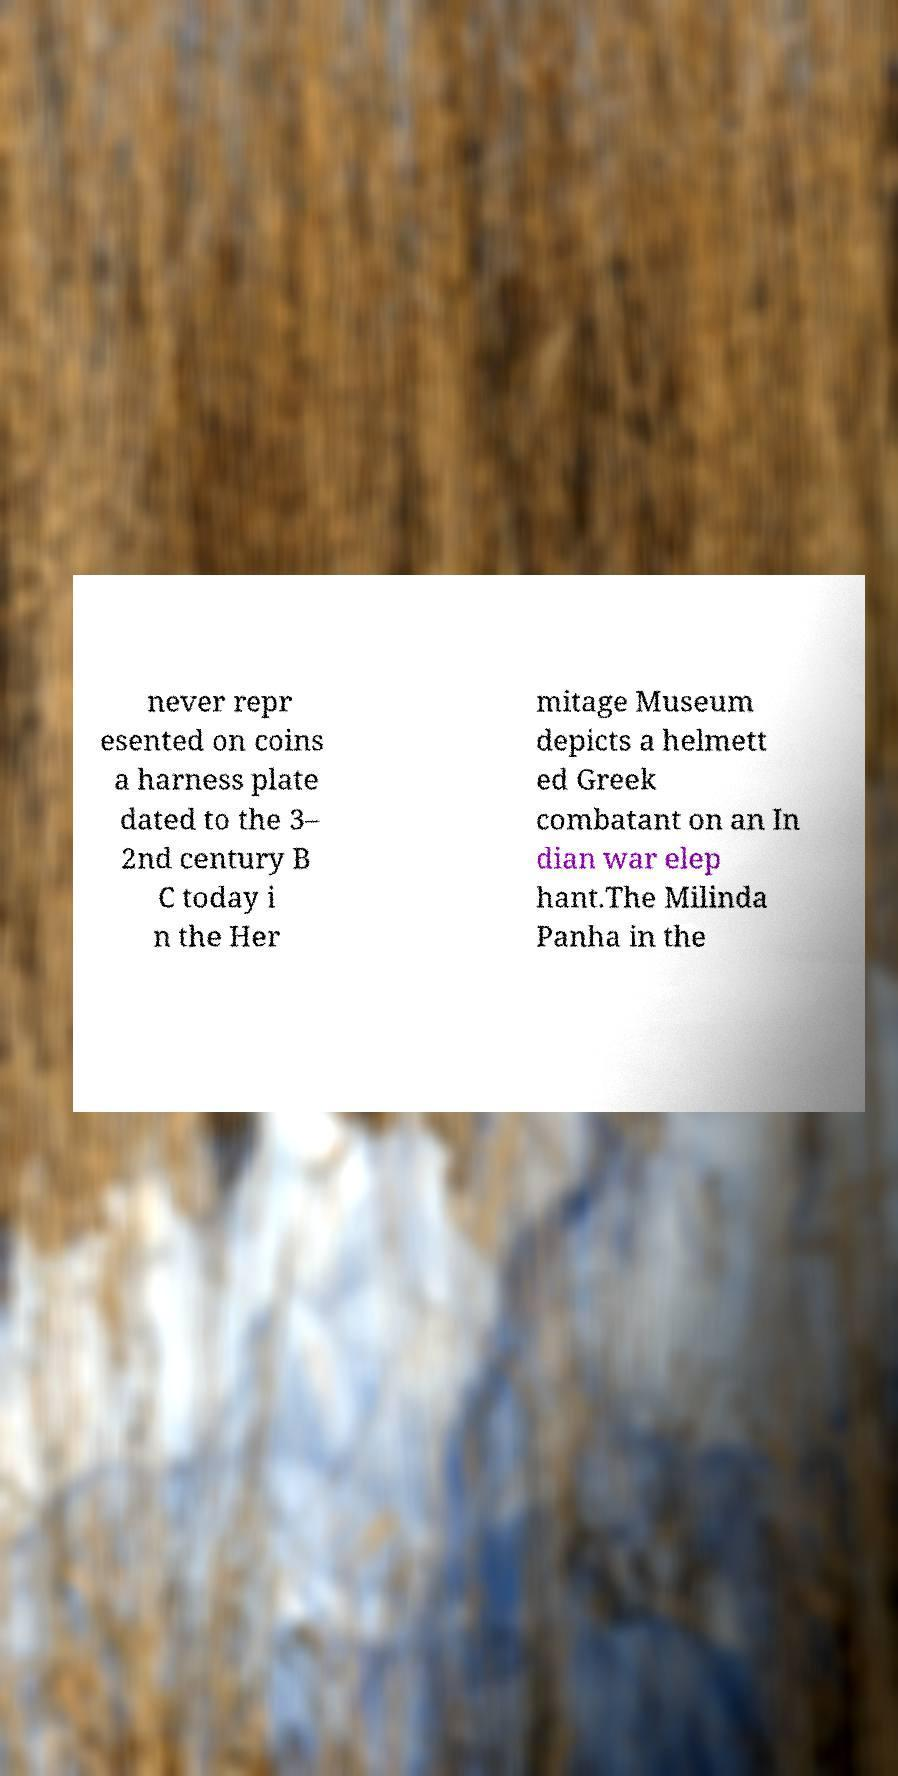Could you extract and type out the text from this image? never repr esented on coins a harness plate dated to the 3– 2nd century B C today i n the Her mitage Museum depicts a helmett ed Greek combatant on an In dian war elep hant.The Milinda Panha in the 